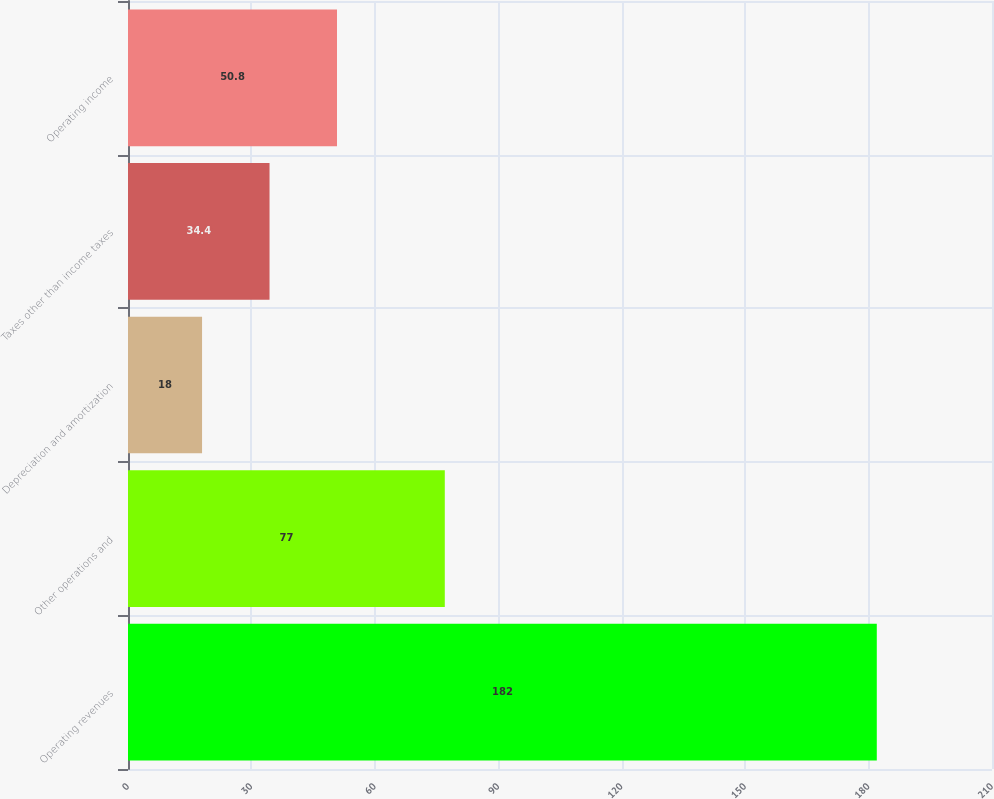Convert chart to OTSL. <chart><loc_0><loc_0><loc_500><loc_500><bar_chart><fcel>Operating revenues<fcel>Other operations and<fcel>Depreciation and amortization<fcel>Taxes other than income taxes<fcel>Operating income<nl><fcel>182<fcel>77<fcel>18<fcel>34.4<fcel>50.8<nl></chart> 